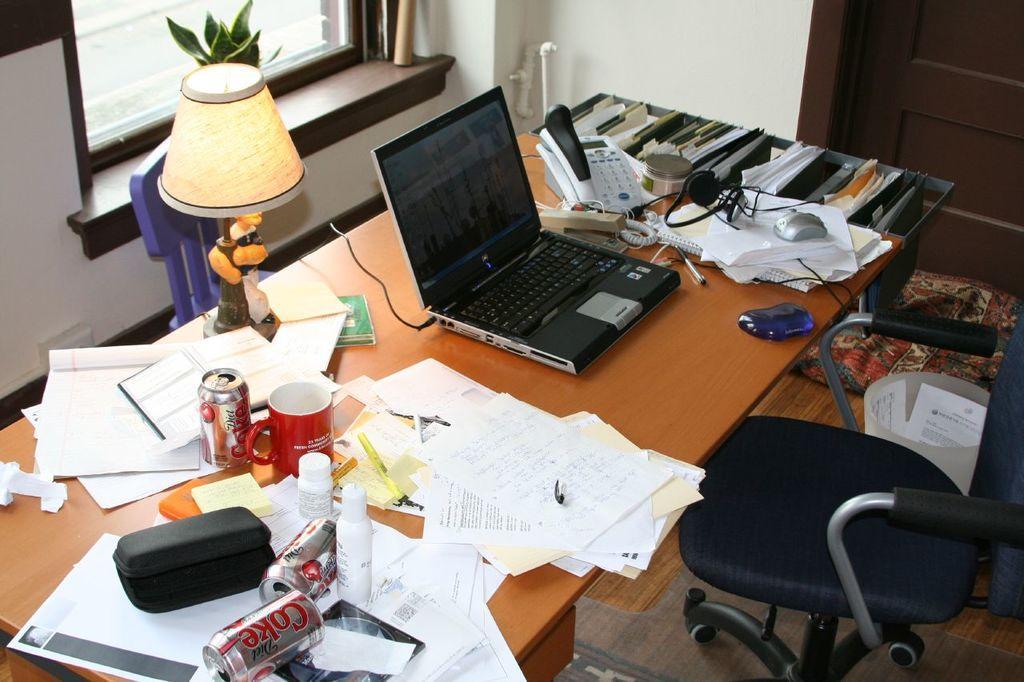In one or two sentences, can you explain what this image depicts? In this image I can see a chair, a brown colored table and on the table I can see few papers, few times, a cup, a telephone, a laptop, few wires, few bottles, a lamp, a mouse and a head set. I can see the wall, a plant, the brown colored door and the window in the background. 